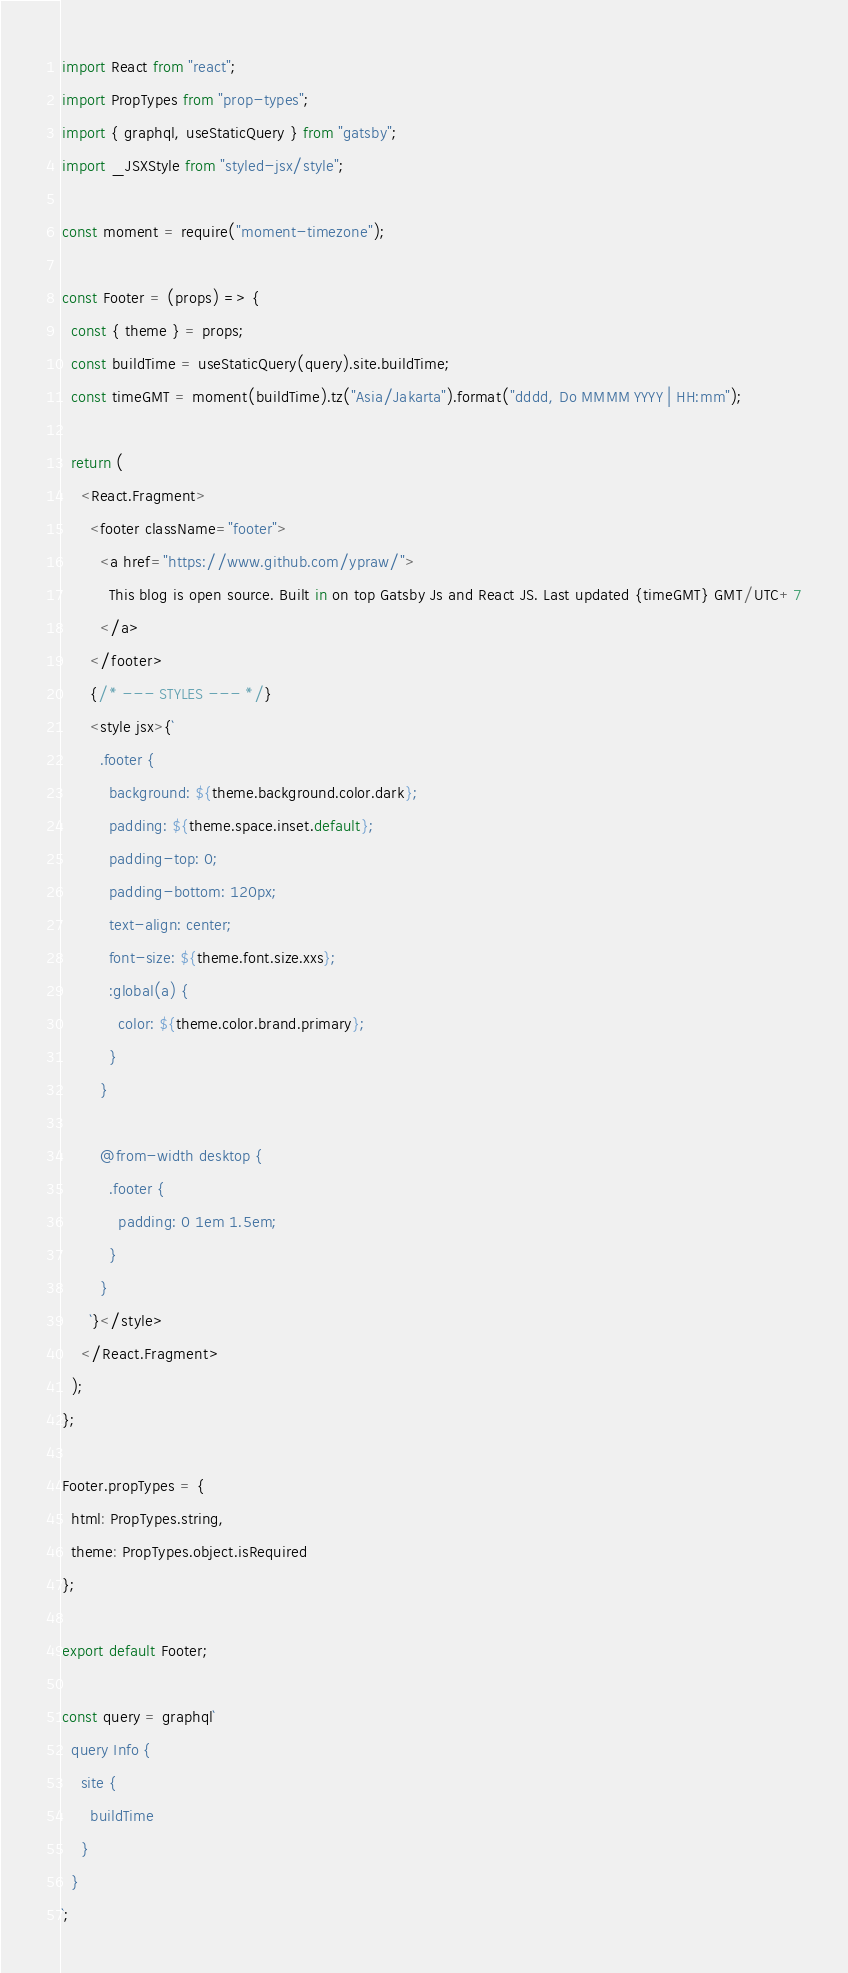<code> <loc_0><loc_0><loc_500><loc_500><_JavaScript_>import React from "react";
import PropTypes from "prop-types";
import { graphql, useStaticQuery } from "gatsby";
import _JSXStyle from "styled-jsx/style";

const moment = require("moment-timezone");

const Footer = (props) => {
  const { theme } = props;
  const buildTime = useStaticQuery(query).site.buildTime;
  const timeGMT = moment(buildTime).tz("Asia/Jakarta").format("dddd, Do MMMM YYYY | HH:mm");

  return (
    <React.Fragment>
      <footer className="footer">
        <a href="https://www.github.com/ypraw/">
          This blog is open source. Built in on top Gatsby Js and React JS. Last updated {timeGMT} GMT/UTC+7
        </a>
      </footer>
      {/* --- STYLES --- */}
      <style jsx>{`
        .footer {
          background: ${theme.background.color.dark};
          padding: ${theme.space.inset.default};
          padding-top: 0;
          padding-bottom: 120px;
          text-align: center;
          font-size: ${theme.font.size.xxs};
          :global(a) {
            color: ${theme.color.brand.primary};
          }
        }

        @from-width desktop {
          .footer {
            padding: 0 1em 1.5em;
          }
        }
      `}</style>
    </React.Fragment>
  );
};

Footer.propTypes = {
  html: PropTypes.string,
  theme: PropTypes.object.isRequired
};

export default Footer;

const query = graphql`
  query Info {
    site {
      buildTime
    }
  }
`;
</code> 